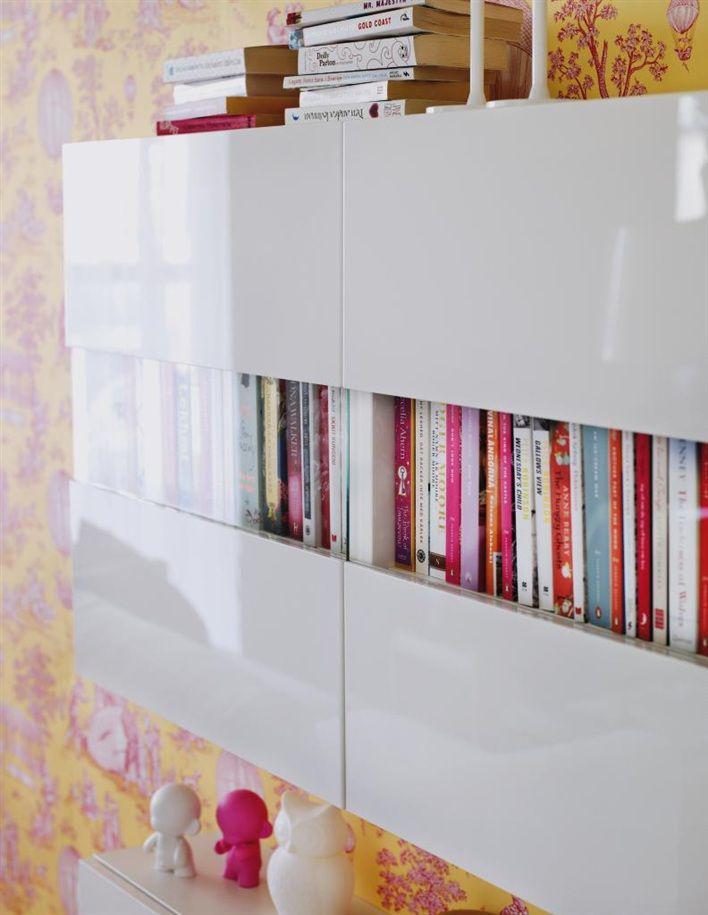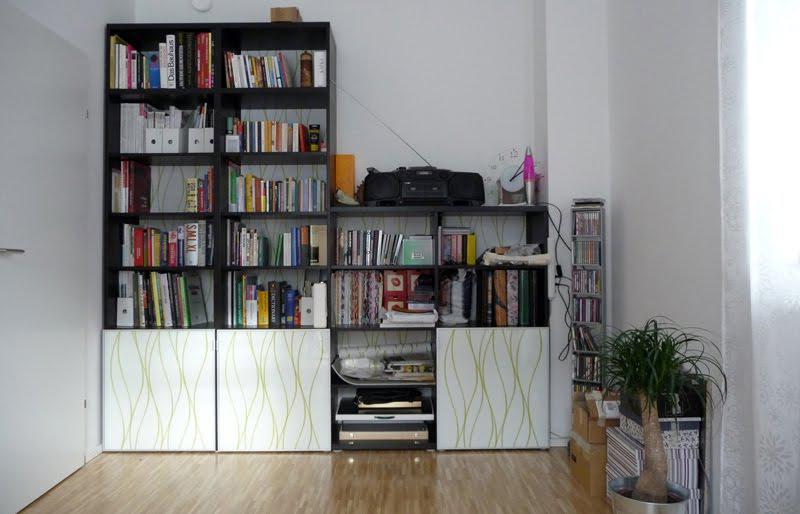The first image is the image on the left, the second image is the image on the right. For the images shown, is this caption "There is one big white bookshelf, with pink back panels and two wicker basket on the bottle left shelf." true? Answer yes or no. No. 